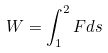Convert formula to latex. <formula><loc_0><loc_0><loc_500><loc_500>W = \int _ { 1 } ^ { 2 } F d s</formula> 